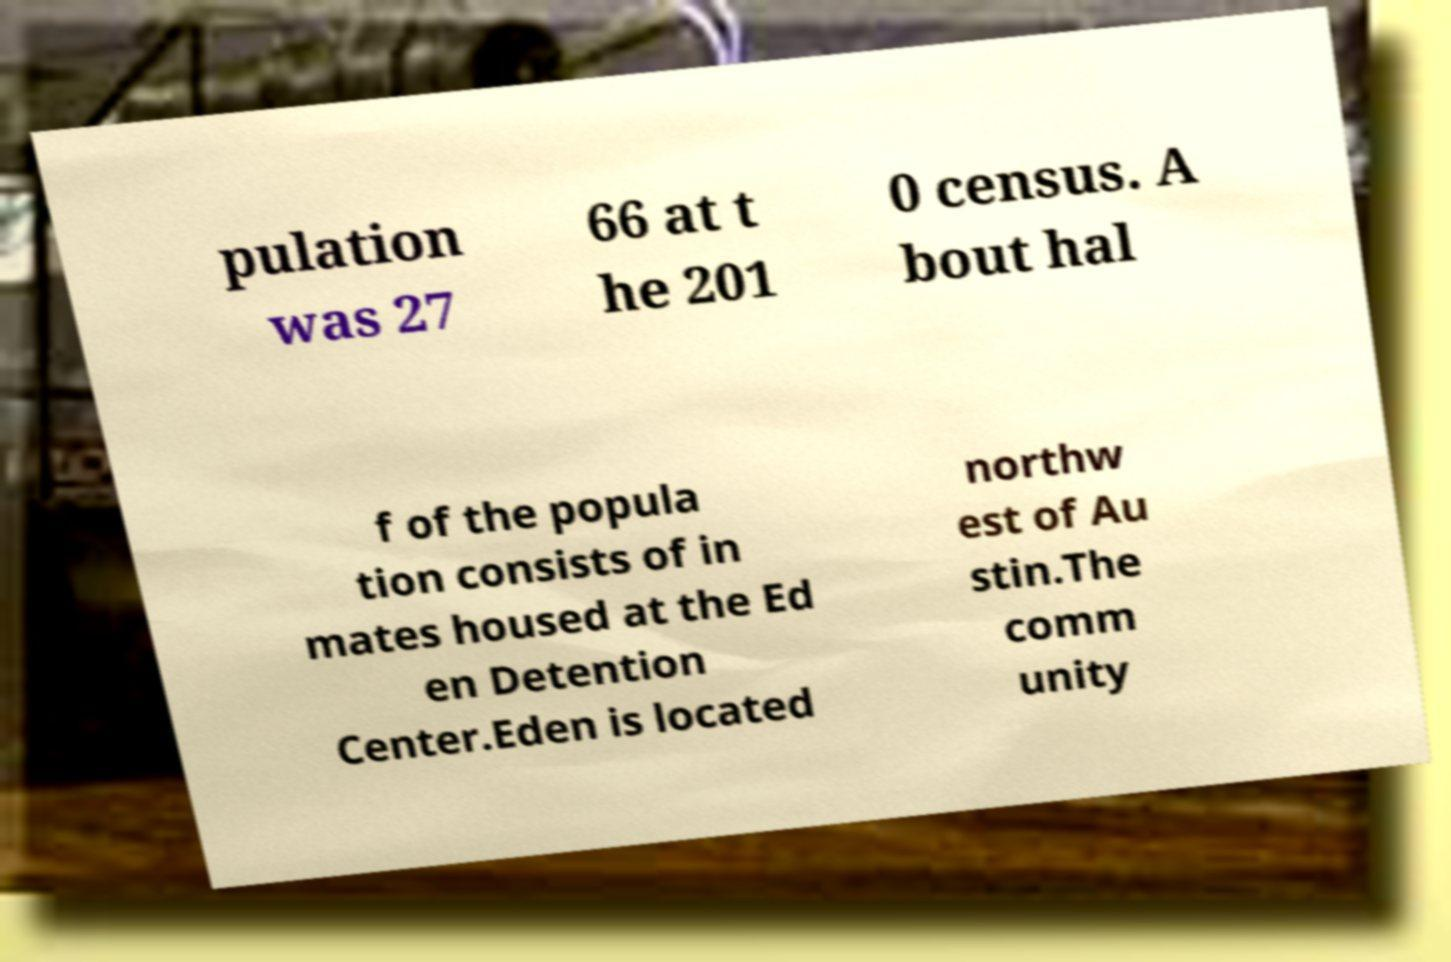Can you accurately transcribe the text from the provided image for me? pulation was 27 66 at t he 201 0 census. A bout hal f of the popula tion consists of in mates housed at the Ed en Detention Center.Eden is located northw est of Au stin.The comm unity 